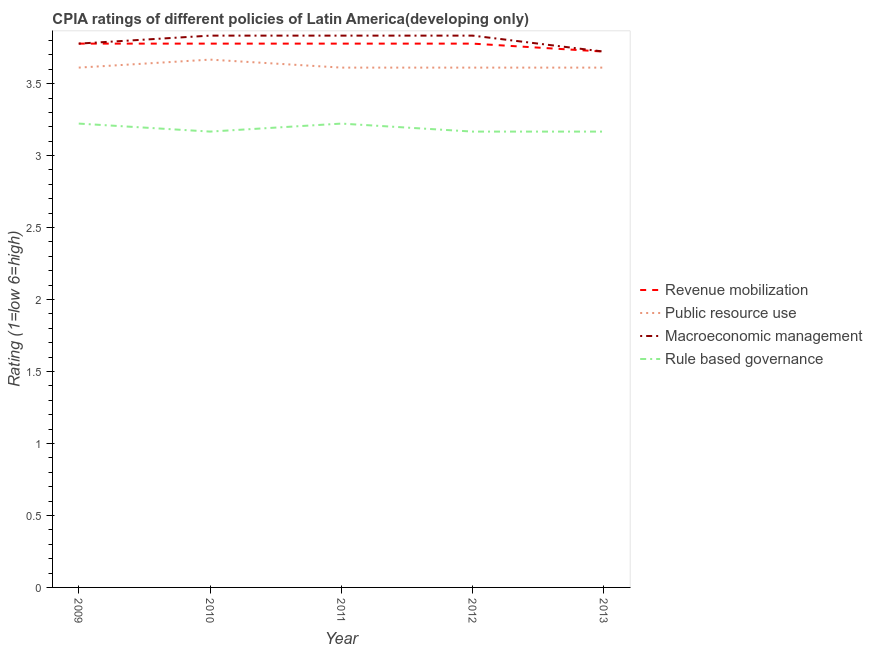Does the line corresponding to cpia rating of macroeconomic management intersect with the line corresponding to cpia rating of public resource use?
Provide a short and direct response. No. Is the number of lines equal to the number of legend labels?
Give a very brief answer. Yes. What is the cpia rating of rule based governance in 2011?
Make the answer very short. 3.22. Across all years, what is the maximum cpia rating of public resource use?
Make the answer very short. 3.67. Across all years, what is the minimum cpia rating of macroeconomic management?
Provide a short and direct response. 3.72. In which year was the cpia rating of rule based governance maximum?
Your response must be concise. 2009. In which year was the cpia rating of revenue mobilization minimum?
Offer a terse response. 2013. What is the total cpia rating of revenue mobilization in the graph?
Keep it short and to the point. 18.83. What is the average cpia rating of public resource use per year?
Your response must be concise. 3.62. In the year 2013, what is the difference between the cpia rating of public resource use and cpia rating of macroeconomic management?
Your answer should be very brief. -0.11. What is the ratio of the cpia rating of rule based governance in 2010 to that in 2012?
Provide a succinct answer. 1. Is the difference between the cpia rating of public resource use in 2010 and 2012 greater than the difference between the cpia rating of rule based governance in 2010 and 2012?
Offer a very short reply. Yes. What is the difference between the highest and the lowest cpia rating of revenue mobilization?
Give a very brief answer. 0.06. In how many years, is the cpia rating of revenue mobilization greater than the average cpia rating of revenue mobilization taken over all years?
Your response must be concise. 4. Is the sum of the cpia rating of revenue mobilization in 2010 and 2013 greater than the maximum cpia rating of macroeconomic management across all years?
Your answer should be very brief. Yes. Is it the case that in every year, the sum of the cpia rating of macroeconomic management and cpia rating of rule based governance is greater than the sum of cpia rating of public resource use and cpia rating of revenue mobilization?
Ensure brevity in your answer.  Yes. Is it the case that in every year, the sum of the cpia rating of revenue mobilization and cpia rating of public resource use is greater than the cpia rating of macroeconomic management?
Provide a short and direct response. Yes. Is the cpia rating of public resource use strictly less than the cpia rating of macroeconomic management over the years?
Offer a very short reply. Yes. What is the difference between two consecutive major ticks on the Y-axis?
Offer a very short reply. 0.5. Are the values on the major ticks of Y-axis written in scientific E-notation?
Offer a terse response. No. Does the graph contain grids?
Give a very brief answer. No. Where does the legend appear in the graph?
Make the answer very short. Center right. How many legend labels are there?
Provide a short and direct response. 4. How are the legend labels stacked?
Give a very brief answer. Vertical. What is the title of the graph?
Your response must be concise. CPIA ratings of different policies of Latin America(developing only). What is the label or title of the X-axis?
Give a very brief answer. Year. What is the label or title of the Y-axis?
Ensure brevity in your answer.  Rating (1=low 6=high). What is the Rating (1=low 6=high) in Revenue mobilization in 2009?
Give a very brief answer. 3.78. What is the Rating (1=low 6=high) in Public resource use in 2009?
Keep it short and to the point. 3.61. What is the Rating (1=low 6=high) in Macroeconomic management in 2009?
Your response must be concise. 3.78. What is the Rating (1=low 6=high) of Rule based governance in 2009?
Make the answer very short. 3.22. What is the Rating (1=low 6=high) in Revenue mobilization in 2010?
Make the answer very short. 3.78. What is the Rating (1=low 6=high) of Public resource use in 2010?
Provide a succinct answer. 3.67. What is the Rating (1=low 6=high) in Macroeconomic management in 2010?
Make the answer very short. 3.83. What is the Rating (1=low 6=high) in Rule based governance in 2010?
Provide a succinct answer. 3.17. What is the Rating (1=low 6=high) of Revenue mobilization in 2011?
Ensure brevity in your answer.  3.78. What is the Rating (1=low 6=high) in Public resource use in 2011?
Make the answer very short. 3.61. What is the Rating (1=low 6=high) of Macroeconomic management in 2011?
Ensure brevity in your answer.  3.83. What is the Rating (1=low 6=high) in Rule based governance in 2011?
Your answer should be compact. 3.22. What is the Rating (1=low 6=high) in Revenue mobilization in 2012?
Your answer should be very brief. 3.78. What is the Rating (1=low 6=high) in Public resource use in 2012?
Your answer should be compact. 3.61. What is the Rating (1=low 6=high) of Macroeconomic management in 2012?
Your answer should be very brief. 3.83. What is the Rating (1=low 6=high) in Rule based governance in 2012?
Your response must be concise. 3.17. What is the Rating (1=low 6=high) in Revenue mobilization in 2013?
Your answer should be very brief. 3.72. What is the Rating (1=low 6=high) in Public resource use in 2013?
Offer a terse response. 3.61. What is the Rating (1=low 6=high) of Macroeconomic management in 2013?
Offer a terse response. 3.72. What is the Rating (1=low 6=high) in Rule based governance in 2013?
Your answer should be compact. 3.17. Across all years, what is the maximum Rating (1=low 6=high) of Revenue mobilization?
Make the answer very short. 3.78. Across all years, what is the maximum Rating (1=low 6=high) of Public resource use?
Your answer should be very brief. 3.67. Across all years, what is the maximum Rating (1=low 6=high) of Macroeconomic management?
Offer a terse response. 3.83. Across all years, what is the maximum Rating (1=low 6=high) of Rule based governance?
Make the answer very short. 3.22. Across all years, what is the minimum Rating (1=low 6=high) of Revenue mobilization?
Offer a very short reply. 3.72. Across all years, what is the minimum Rating (1=low 6=high) in Public resource use?
Your answer should be compact. 3.61. Across all years, what is the minimum Rating (1=low 6=high) in Macroeconomic management?
Keep it short and to the point. 3.72. Across all years, what is the minimum Rating (1=low 6=high) in Rule based governance?
Offer a terse response. 3.17. What is the total Rating (1=low 6=high) of Revenue mobilization in the graph?
Make the answer very short. 18.83. What is the total Rating (1=low 6=high) of Public resource use in the graph?
Provide a succinct answer. 18.11. What is the total Rating (1=low 6=high) in Rule based governance in the graph?
Provide a succinct answer. 15.94. What is the difference between the Rating (1=low 6=high) of Revenue mobilization in 2009 and that in 2010?
Provide a short and direct response. 0. What is the difference between the Rating (1=low 6=high) of Public resource use in 2009 and that in 2010?
Your answer should be very brief. -0.06. What is the difference between the Rating (1=low 6=high) of Macroeconomic management in 2009 and that in 2010?
Ensure brevity in your answer.  -0.06. What is the difference between the Rating (1=low 6=high) in Rule based governance in 2009 and that in 2010?
Offer a very short reply. 0.06. What is the difference between the Rating (1=low 6=high) of Revenue mobilization in 2009 and that in 2011?
Offer a very short reply. 0. What is the difference between the Rating (1=low 6=high) of Macroeconomic management in 2009 and that in 2011?
Offer a very short reply. -0.06. What is the difference between the Rating (1=low 6=high) in Rule based governance in 2009 and that in 2011?
Give a very brief answer. 0. What is the difference between the Rating (1=low 6=high) in Macroeconomic management in 2009 and that in 2012?
Offer a terse response. -0.06. What is the difference between the Rating (1=low 6=high) in Rule based governance in 2009 and that in 2012?
Offer a very short reply. 0.06. What is the difference between the Rating (1=low 6=high) of Revenue mobilization in 2009 and that in 2013?
Give a very brief answer. 0.06. What is the difference between the Rating (1=low 6=high) of Macroeconomic management in 2009 and that in 2013?
Give a very brief answer. 0.06. What is the difference between the Rating (1=low 6=high) of Rule based governance in 2009 and that in 2013?
Ensure brevity in your answer.  0.06. What is the difference between the Rating (1=low 6=high) in Revenue mobilization in 2010 and that in 2011?
Offer a terse response. 0. What is the difference between the Rating (1=low 6=high) of Public resource use in 2010 and that in 2011?
Ensure brevity in your answer.  0.06. What is the difference between the Rating (1=low 6=high) in Macroeconomic management in 2010 and that in 2011?
Make the answer very short. 0. What is the difference between the Rating (1=low 6=high) of Rule based governance in 2010 and that in 2011?
Provide a succinct answer. -0.06. What is the difference between the Rating (1=low 6=high) in Public resource use in 2010 and that in 2012?
Your response must be concise. 0.06. What is the difference between the Rating (1=low 6=high) in Rule based governance in 2010 and that in 2012?
Offer a very short reply. 0. What is the difference between the Rating (1=low 6=high) of Revenue mobilization in 2010 and that in 2013?
Provide a succinct answer. 0.06. What is the difference between the Rating (1=low 6=high) of Public resource use in 2010 and that in 2013?
Your response must be concise. 0.06. What is the difference between the Rating (1=low 6=high) in Macroeconomic management in 2010 and that in 2013?
Provide a short and direct response. 0.11. What is the difference between the Rating (1=low 6=high) in Revenue mobilization in 2011 and that in 2012?
Provide a short and direct response. 0. What is the difference between the Rating (1=low 6=high) in Macroeconomic management in 2011 and that in 2012?
Keep it short and to the point. 0. What is the difference between the Rating (1=low 6=high) in Rule based governance in 2011 and that in 2012?
Keep it short and to the point. 0.06. What is the difference between the Rating (1=low 6=high) in Revenue mobilization in 2011 and that in 2013?
Provide a short and direct response. 0.06. What is the difference between the Rating (1=low 6=high) of Public resource use in 2011 and that in 2013?
Provide a succinct answer. 0. What is the difference between the Rating (1=low 6=high) in Macroeconomic management in 2011 and that in 2013?
Keep it short and to the point. 0.11. What is the difference between the Rating (1=low 6=high) in Rule based governance in 2011 and that in 2013?
Offer a very short reply. 0.06. What is the difference between the Rating (1=low 6=high) in Revenue mobilization in 2012 and that in 2013?
Provide a succinct answer. 0.06. What is the difference between the Rating (1=low 6=high) in Rule based governance in 2012 and that in 2013?
Offer a terse response. 0. What is the difference between the Rating (1=low 6=high) in Revenue mobilization in 2009 and the Rating (1=low 6=high) in Public resource use in 2010?
Make the answer very short. 0.11. What is the difference between the Rating (1=low 6=high) of Revenue mobilization in 2009 and the Rating (1=low 6=high) of Macroeconomic management in 2010?
Make the answer very short. -0.06. What is the difference between the Rating (1=low 6=high) of Revenue mobilization in 2009 and the Rating (1=low 6=high) of Rule based governance in 2010?
Keep it short and to the point. 0.61. What is the difference between the Rating (1=low 6=high) in Public resource use in 2009 and the Rating (1=low 6=high) in Macroeconomic management in 2010?
Your answer should be very brief. -0.22. What is the difference between the Rating (1=low 6=high) in Public resource use in 2009 and the Rating (1=low 6=high) in Rule based governance in 2010?
Give a very brief answer. 0.44. What is the difference between the Rating (1=low 6=high) in Macroeconomic management in 2009 and the Rating (1=low 6=high) in Rule based governance in 2010?
Give a very brief answer. 0.61. What is the difference between the Rating (1=low 6=high) of Revenue mobilization in 2009 and the Rating (1=low 6=high) of Macroeconomic management in 2011?
Your answer should be compact. -0.06. What is the difference between the Rating (1=low 6=high) in Revenue mobilization in 2009 and the Rating (1=low 6=high) in Rule based governance in 2011?
Your answer should be very brief. 0.56. What is the difference between the Rating (1=low 6=high) in Public resource use in 2009 and the Rating (1=low 6=high) in Macroeconomic management in 2011?
Ensure brevity in your answer.  -0.22. What is the difference between the Rating (1=low 6=high) in Public resource use in 2009 and the Rating (1=low 6=high) in Rule based governance in 2011?
Offer a terse response. 0.39. What is the difference between the Rating (1=low 6=high) of Macroeconomic management in 2009 and the Rating (1=low 6=high) of Rule based governance in 2011?
Ensure brevity in your answer.  0.56. What is the difference between the Rating (1=low 6=high) of Revenue mobilization in 2009 and the Rating (1=low 6=high) of Public resource use in 2012?
Give a very brief answer. 0.17. What is the difference between the Rating (1=low 6=high) of Revenue mobilization in 2009 and the Rating (1=low 6=high) of Macroeconomic management in 2012?
Make the answer very short. -0.06. What is the difference between the Rating (1=low 6=high) of Revenue mobilization in 2009 and the Rating (1=low 6=high) of Rule based governance in 2012?
Offer a terse response. 0.61. What is the difference between the Rating (1=low 6=high) in Public resource use in 2009 and the Rating (1=low 6=high) in Macroeconomic management in 2012?
Your answer should be very brief. -0.22. What is the difference between the Rating (1=low 6=high) in Public resource use in 2009 and the Rating (1=low 6=high) in Rule based governance in 2012?
Your answer should be compact. 0.44. What is the difference between the Rating (1=low 6=high) of Macroeconomic management in 2009 and the Rating (1=low 6=high) of Rule based governance in 2012?
Keep it short and to the point. 0.61. What is the difference between the Rating (1=low 6=high) in Revenue mobilization in 2009 and the Rating (1=low 6=high) in Public resource use in 2013?
Keep it short and to the point. 0.17. What is the difference between the Rating (1=low 6=high) in Revenue mobilization in 2009 and the Rating (1=low 6=high) in Macroeconomic management in 2013?
Give a very brief answer. 0.06. What is the difference between the Rating (1=low 6=high) of Revenue mobilization in 2009 and the Rating (1=low 6=high) of Rule based governance in 2013?
Give a very brief answer. 0.61. What is the difference between the Rating (1=low 6=high) in Public resource use in 2009 and the Rating (1=low 6=high) in Macroeconomic management in 2013?
Keep it short and to the point. -0.11. What is the difference between the Rating (1=low 6=high) in Public resource use in 2009 and the Rating (1=low 6=high) in Rule based governance in 2013?
Offer a terse response. 0.44. What is the difference between the Rating (1=low 6=high) of Macroeconomic management in 2009 and the Rating (1=low 6=high) of Rule based governance in 2013?
Keep it short and to the point. 0.61. What is the difference between the Rating (1=low 6=high) of Revenue mobilization in 2010 and the Rating (1=low 6=high) of Public resource use in 2011?
Offer a terse response. 0.17. What is the difference between the Rating (1=low 6=high) of Revenue mobilization in 2010 and the Rating (1=low 6=high) of Macroeconomic management in 2011?
Provide a short and direct response. -0.06. What is the difference between the Rating (1=low 6=high) in Revenue mobilization in 2010 and the Rating (1=low 6=high) in Rule based governance in 2011?
Your answer should be very brief. 0.56. What is the difference between the Rating (1=low 6=high) in Public resource use in 2010 and the Rating (1=low 6=high) in Macroeconomic management in 2011?
Provide a succinct answer. -0.17. What is the difference between the Rating (1=low 6=high) of Public resource use in 2010 and the Rating (1=low 6=high) of Rule based governance in 2011?
Your response must be concise. 0.44. What is the difference between the Rating (1=low 6=high) of Macroeconomic management in 2010 and the Rating (1=low 6=high) of Rule based governance in 2011?
Provide a short and direct response. 0.61. What is the difference between the Rating (1=low 6=high) of Revenue mobilization in 2010 and the Rating (1=low 6=high) of Macroeconomic management in 2012?
Offer a terse response. -0.06. What is the difference between the Rating (1=low 6=high) of Revenue mobilization in 2010 and the Rating (1=low 6=high) of Rule based governance in 2012?
Ensure brevity in your answer.  0.61. What is the difference between the Rating (1=low 6=high) in Public resource use in 2010 and the Rating (1=low 6=high) in Macroeconomic management in 2012?
Offer a very short reply. -0.17. What is the difference between the Rating (1=low 6=high) in Revenue mobilization in 2010 and the Rating (1=low 6=high) in Macroeconomic management in 2013?
Offer a terse response. 0.06. What is the difference between the Rating (1=low 6=high) in Revenue mobilization in 2010 and the Rating (1=low 6=high) in Rule based governance in 2013?
Offer a terse response. 0.61. What is the difference between the Rating (1=low 6=high) in Public resource use in 2010 and the Rating (1=low 6=high) in Macroeconomic management in 2013?
Give a very brief answer. -0.06. What is the difference between the Rating (1=low 6=high) of Public resource use in 2010 and the Rating (1=low 6=high) of Rule based governance in 2013?
Make the answer very short. 0.5. What is the difference between the Rating (1=low 6=high) of Macroeconomic management in 2010 and the Rating (1=low 6=high) of Rule based governance in 2013?
Your answer should be very brief. 0.67. What is the difference between the Rating (1=low 6=high) in Revenue mobilization in 2011 and the Rating (1=low 6=high) in Macroeconomic management in 2012?
Provide a succinct answer. -0.06. What is the difference between the Rating (1=low 6=high) in Revenue mobilization in 2011 and the Rating (1=low 6=high) in Rule based governance in 2012?
Provide a short and direct response. 0.61. What is the difference between the Rating (1=low 6=high) in Public resource use in 2011 and the Rating (1=low 6=high) in Macroeconomic management in 2012?
Offer a terse response. -0.22. What is the difference between the Rating (1=low 6=high) of Public resource use in 2011 and the Rating (1=low 6=high) of Rule based governance in 2012?
Your answer should be compact. 0.44. What is the difference between the Rating (1=low 6=high) in Macroeconomic management in 2011 and the Rating (1=low 6=high) in Rule based governance in 2012?
Keep it short and to the point. 0.67. What is the difference between the Rating (1=low 6=high) in Revenue mobilization in 2011 and the Rating (1=low 6=high) in Macroeconomic management in 2013?
Offer a terse response. 0.06. What is the difference between the Rating (1=low 6=high) of Revenue mobilization in 2011 and the Rating (1=low 6=high) of Rule based governance in 2013?
Make the answer very short. 0.61. What is the difference between the Rating (1=low 6=high) of Public resource use in 2011 and the Rating (1=low 6=high) of Macroeconomic management in 2013?
Your answer should be compact. -0.11. What is the difference between the Rating (1=low 6=high) in Public resource use in 2011 and the Rating (1=low 6=high) in Rule based governance in 2013?
Offer a terse response. 0.44. What is the difference between the Rating (1=low 6=high) of Macroeconomic management in 2011 and the Rating (1=low 6=high) of Rule based governance in 2013?
Your answer should be compact. 0.67. What is the difference between the Rating (1=low 6=high) of Revenue mobilization in 2012 and the Rating (1=low 6=high) of Public resource use in 2013?
Give a very brief answer. 0.17. What is the difference between the Rating (1=low 6=high) of Revenue mobilization in 2012 and the Rating (1=low 6=high) of Macroeconomic management in 2013?
Your answer should be very brief. 0.06. What is the difference between the Rating (1=low 6=high) in Revenue mobilization in 2012 and the Rating (1=low 6=high) in Rule based governance in 2013?
Your answer should be very brief. 0.61. What is the difference between the Rating (1=low 6=high) in Public resource use in 2012 and the Rating (1=low 6=high) in Macroeconomic management in 2013?
Ensure brevity in your answer.  -0.11. What is the difference between the Rating (1=low 6=high) of Public resource use in 2012 and the Rating (1=low 6=high) of Rule based governance in 2013?
Ensure brevity in your answer.  0.44. What is the average Rating (1=low 6=high) in Revenue mobilization per year?
Provide a short and direct response. 3.77. What is the average Rating (1=low 6=high) of Public resource use per year?
Offer a very short reply. 3.62. What is the average Rating (1=low 6=high) in Macroeconomic management per year?
Offer a terse response. 3.8. What is the average Rating (1=low 6=high) in Rule based governance per year?
Your answer should be very brief. 3.19. In the year 2009, what is the difference between the Rating (1=low 6=high) of Revenue mobilization and Rating (1=low 6=high) of Macroeconomic management?
Offer a very short reply. 0. In the year 2009, what is the difference between the Rating (1=low 6=high) in Revenue mobilization and Rating (1=low 6=high) in Rule based governance?
Your answer should be compact. 0.56. In the year 2009, what is the difference between the Rating (1=low 6=high) of Public resource use and Rating (1=low 6=high) of Rule based governance?
Provide a succinct answer. 0.39. In the year 2009, what is the difference between the Rating (1=low 6=high) of Macroeconomic management and Rating (1=low 6=high) of Rule based governance?
Provide a short and direct response. 0.56. In the year 2010, what is the difference between the Rating (1=low 6=high) in Revenue mobilization and Rating (1=low 6=high) in Public resource use?
Keep it short and to the point. 0.11. In the year 2010, what is the difference between the Rating (1=low 6=high) in Revenue mobilization and Rating (1=low 6=high) in Macroeconomic management?
Your answer should be very brief. -0.06. In the year 2010, what is the difference between the Rating (1=low 6=high) in Revenue mobilization and Rating (1=low 6=high) in Rule based governance?
Offer a terse response. 0.61. In the year 2011, what is the difference between the Rating (1=low 6=high) of Revenue mobilization and Rating (1=low 6=high) of Public resource use?
Offer a very short reply. 0.17. In the year 2011, what is the difference between the Rating (1=low 6=high) in Revenue mobilization and Rating (1=low 6=high) in Macroeconomic management?
Offer a terse response. -0.06. In the year 2011, what is the difference between the Rating (1=low 6=high) in Revenue mobilization and Rating (1=low 6=high) in Rule based governance?
Ensure brevity in your answer.  0.56. In the year 2011, what is the difference between the Rating (1=low 6=high) in Public resource use and Rating (1=low 6=high) in Macroeconomic management?
Offer a terse response. -0.22. In the year 2011, what is the difference between the Rating (1=low 6=high) of Public resource use and Rating (1=low 6=high) of Rule based governance?
Provide a succinct answer. 0.39. In the year 2011, what is the difference between the Rating (1=low 6=high) in Macroeconomic management and Rating (1=low 6=high) in Rule based governance?
Provide a succinct answer. 0.61. In the year 2012, what is the difference between the Rating (1=low 6=high) in Revenue mobilization and Rating (1=low 6=high) in Public resource use?
Your answer should be compact. 0.17. In the year 2012, what is the difference between the Rating (1=low 6=high) of Revenue mobilization and Rating (1=low 6=high) of Macroeconomic management?
Your response must be concise. -0.06. In the year 2012, what is the difference between the Rating (1=low 6=high) of Revenue mobilization and Rating (1=low 6=high) of Rule based governance?
Give a very brief answer. 0.61. In the year 2012, what is the difference between the Rating (1=low 6=high) of Public resource use and Rating (1=low 6=high) of Macroeconomic management?
Your response must be concise. -0.22. In the year 2012, what is the difference between the Rating (1=low 6=high) in Public resource use and Rating (1=low 6=high) in Rule based governance?
Offer a terse response. 0.44. In the year 2012, what is the difference between the Rating (1=low 6=high) of Macroeconomic management and Rating (1=low 6=high) of Rule based governance?
Provide a succinct answer. 0.67. In the year 2013, what is the difference between the Rating (1=low 6=high) in Revenue mobilization and Rating (1=low 6=high) in Rule based governance?
Your answer should be very brief. 0.56. In the year 2013, what is the difference between the Rating (1=low 6=high) of Public resource use and Rating (1=low 6=high) of Macroeconomic management?
Give a very brief answer. -0.11. In the year 2013, what is the difference between the Rating (1=low 6=high) of Public resource use and Rating (1=low 6=high) of Rule based governance?
Ensure brevity in your answer.  0.44. In the year 2013, what is the difference between the Rating (1=low 6=high) in Macroeconomic management and Rating (1=low 6=high) in Rule based governance?
Offer a very short reply. 0.56. What is the ratio of the Rating (1=low 6=high) in Revenue mobilization in 2009 to that in 2010?
Provide a succinct answer. 1. What is the ratio of the Rating (1=low 6=high) in Public resource use in 2009 to that in 2010?
Your answer should be compact. 0.98. What is the ratio of the Rating (1=low 6=high) in Macroeconomic management in 2009 to that in 2010?
Ensure brevity in your answer.  0.99. What is the ratio of the Rating (1=low 6=high) of Rule based governance in 2009 to that in 2010?
Offer a very short reply. 1.02. What is the ratio of the Rating (1=low 6=high) in Revenue mobilization in 2009 to that in 2011?
Offer a very short reply. 1. What is the ratio of the Rating (1=low 6=high) of Macroeconomic management in 2009 to that in 2011?
Offer a very short reply. 0.99. What is the ratio of the Rating (1=low 6=high) in Rule based governance in 2009 to that in 2011?
Offer a very short reply. 1. What is the ratio of the Rating (1=low 6=high) in Revenue mobilization in 2009 to that in 2012?
Your answer should be very brief. 1. What is the ratio of the Rating (1=low 6=high) of Public resource use in 2009 to that in 2012?
Provide a succinct answer. 1. What is the ratio of the Rating (1=low 6=high) in Macroeconomic management in 2009 to that in 2012?
Provide a short and direct response. 0.99. What is the ratio of the Rating (1=low 6=high) in Rule based governance in 2009 to that in 2012?
Offer a very short reply. 1.02. What is the ratio of the Rating (1=low 6=high) in Revenue mobilization in 2009 to that in 2013?
Keep it short and to the point. 1.01. What is the ratio of the Rating (1=low 6=high) in Macroeconomic management in 2009 to that in 2013?
Keep it short and to the point. 1.01. What is the ratio of the Rating (1=low 6=high) in Rule based governance in 2009 to that in 2013?
Your answer should be compact. 1.02. What is the ratio of the Rating (1=low 6=high) in Revenue mobilization in 2010 to that in 2011?
Your answer should be compact. 1. What is the ratio of the Rating (1=low 6=high) of Public resource use in 2010 to that in 2011?
Give a very brief answer. 1.02. What is the ratio of the Rating (1=low 6=high) of Macroeconomic management in 2010 to that in 2011?
Provide a short and direct response. 1. What is the ratio of the Rating (1=low 6=high) in Rule based governance in 2010 to that in 2011?
Ensure brevity in your answer.  0.98. What is the ratio of the Rating (1=low 6=high) of Revenue mobilization in 2010 to that in 2012?
Provide a succinct answer. 1. What is the ratio of the Rating (1=low 6=high) of Public resource use in 2010 to that in 2012?
Offer a very short reply. 1.02. What is the ratio of the Rating (1=low 6=high) in Rule based governance in 2010 to that in 2012?
Ensure brevity in your answer.  1. What is the ratio of the Rating (1=low 6=high) of Revenue mobilization in 2010 to that in 2013?
Your response must be concise. 1.01. What is the ratio of the Rating (1=low 6=high) of Public resource use in 2010 to that in 2013?
Make the answer very short. 1.02. What is the ratio of the Rating (1=low 6=high) in Macroeconomic management in 2010 to that in 2013?
Make the answer very short. 1.03. What is the ratio of the Rating (1=low 6=high) of Revenue mobilization in 2011 to that in 2012?
Provide a succinct answer. 1. What is the ratio of the Rating (1=low 6=high) of Public resource use in 2011 to that in 2012?
Ensure brevity in your answer.  1. What is the ratio of the Rating (1=low 6=high) of Macroeconomic management in 2011 to that in 2012?
Offer a very short reply. 1. What is the ratio of the Rating (1=low 6=high) in Rule based governance in 2011 to that in 2012?
Keep it short and to the point. 1.02. What is the ratio of the Rating (1=low 6=high) of Revenue mobilization in 2011 to that in 2013?
Your response must be concise. 1.01. What is the ratio of the Rating (1=low 6=high) in Public resource use in 2011 to that in 2013?
Your response must be concise. 1. What is the ratio of the Rating (1=low 6=high) of Macroeconomic management in 2011 to that in 2013?
Keep it short and to the point. 1.03. What is the ratio of the Rating (1=low 6=high) in Rule based governance in 2011 to that in 2013?
Your answer should be compact. 1.02. What is the ratio of the Rating (1=low 6=high) in Revenue mobilization in 2012 to that in 2013?
Keep it short and to the point. 1.01. What is the ratio of the Rating (1=low 6=high) in Macroeconomic management in 2012 to that in 2013?
Give a very brief answer. 1.03. What is the ratio of the Rating (1=low 6=high) of Rule based governance in 2012 to that in 2013?
Provide a short and direct response. 1. What is the difference between the highest and the second highest Rating (1=low 6=high) of Revenue mobilization?
Your response must be concise. 0. What is the difference between the highest and the second highest Rating (1=low 6=high) in Public resource use?
Your answer should be very brief. 0.06. What is the difference between the highest and the lowest Rating (1=low 6=high) in Revenue mobilization?
Your answer should be compact. 0.06. What is the difference between the highest and the lowest Rating (1=low 6=high) of Public resource use?
Your answer should be compact. 0.06. What is the difference between the highest and the lowest Rating (1=low 6=high) of Macroeconomic management?
Give a very brief answer. 0.11. What is the difference between the highest and the lowest Rating (1=low 6=high) of Rule based governance?
Make the answer very short. 0.06. 